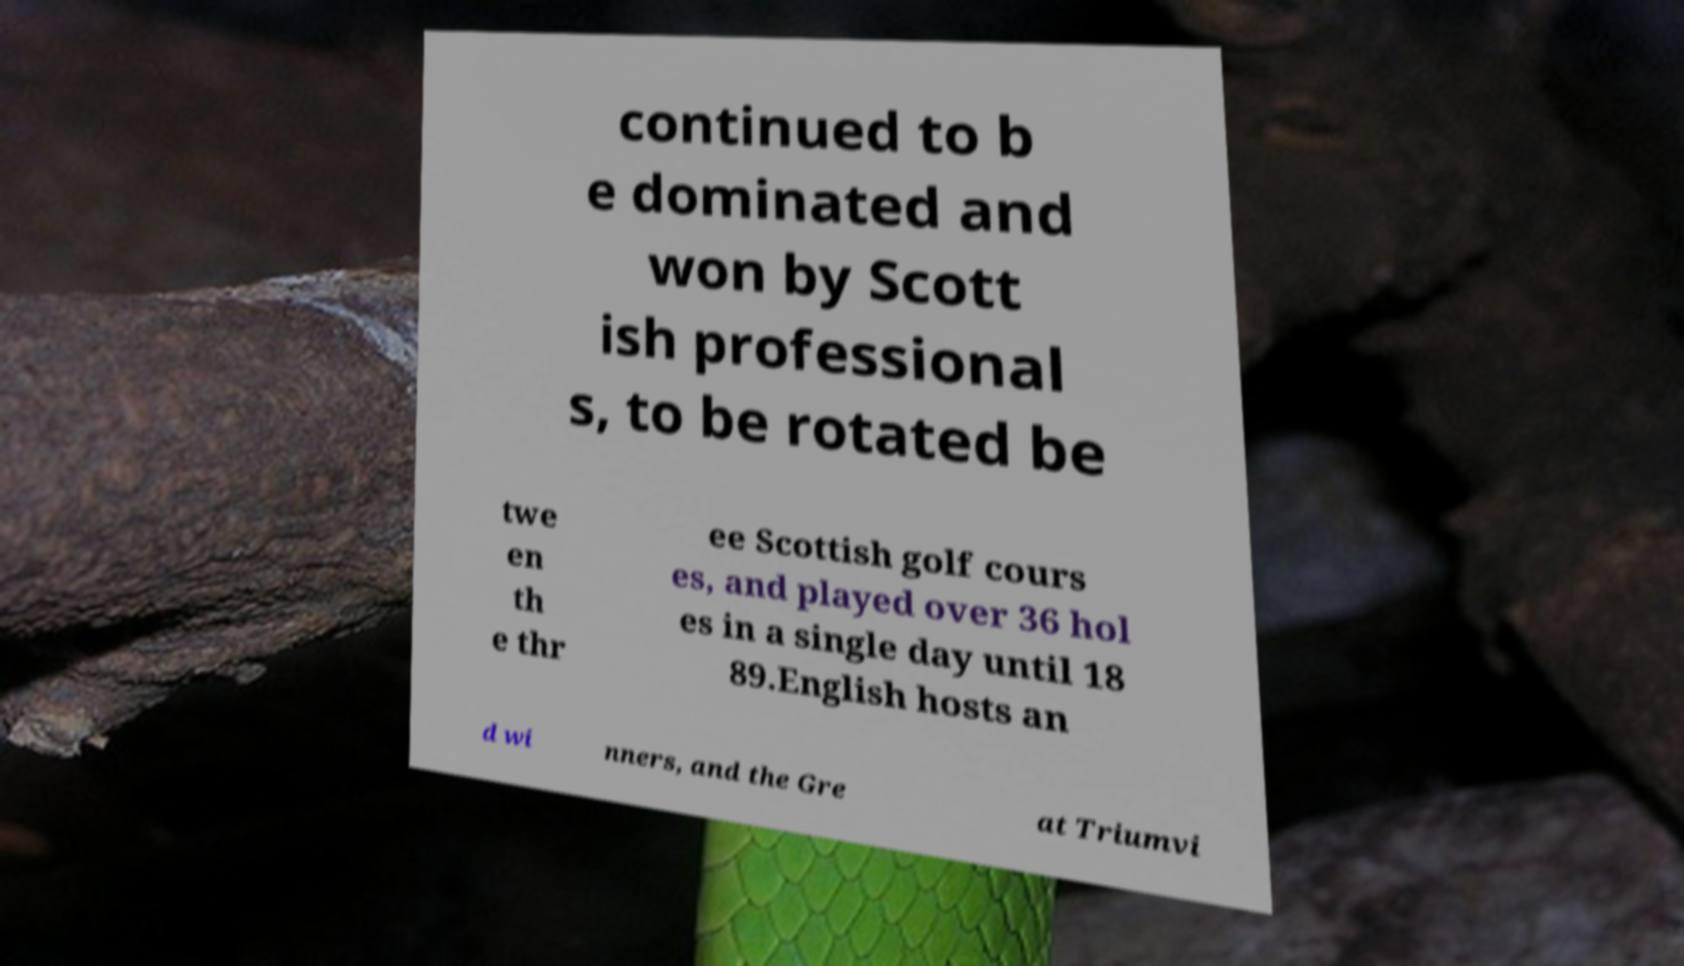Please identify and transcribe the text found in this image. continued to b e dominated and won by Scott ish professional s, to be rotated be twe en th e thr ee Scottish golf cours es, and played over 36 hol es in a single day until 18 89.English hosts an d wi nners, and the Gre at Triumvi 